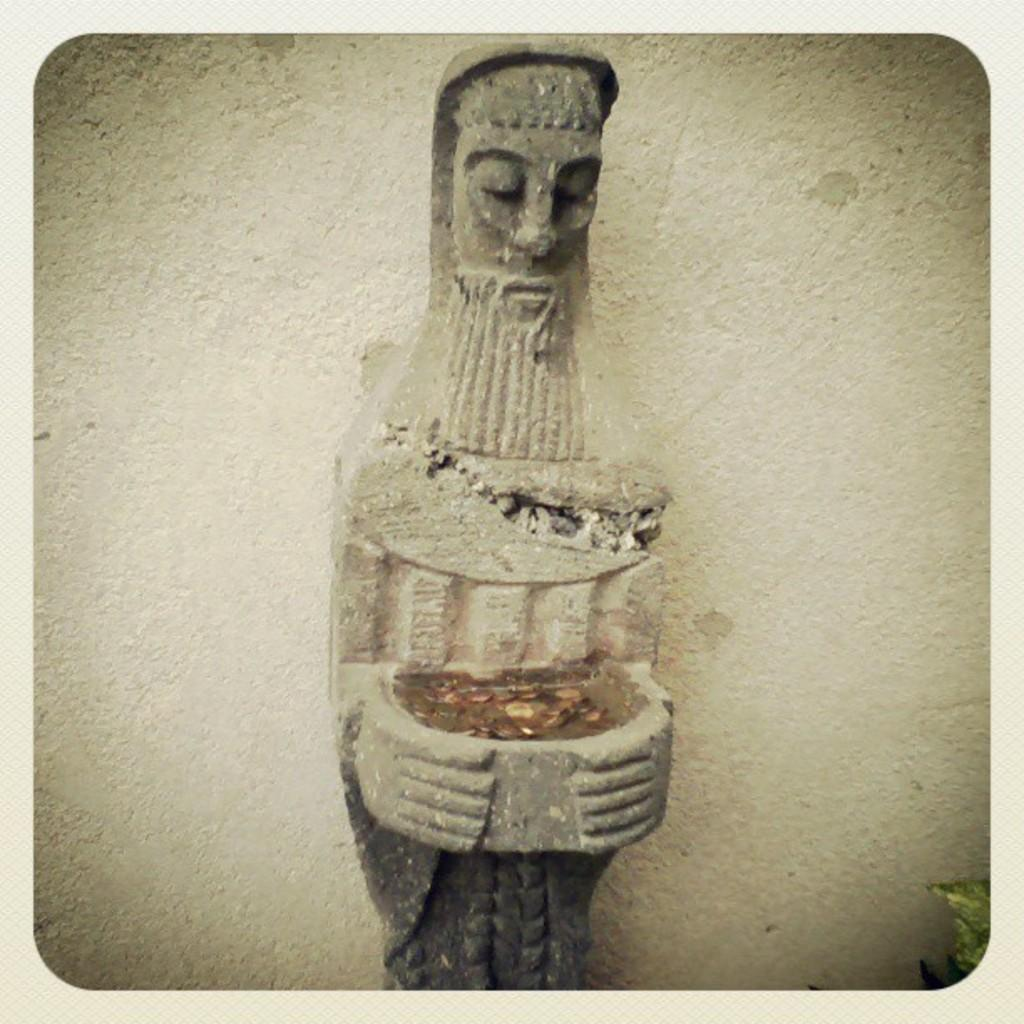What is the main subject in the foreground of the image? There is a sculpture in the foreground of the image. What can be seen in the background of the image? There is a wall in the background of the image. Can you describe any smaller details in the image? Yes, there is a leaf in the bottom right of the image. How many sheep are visible in the image? There are no sheep present in the image. Can you tell me the color of the goat in the image? There is no goat present in the image. 